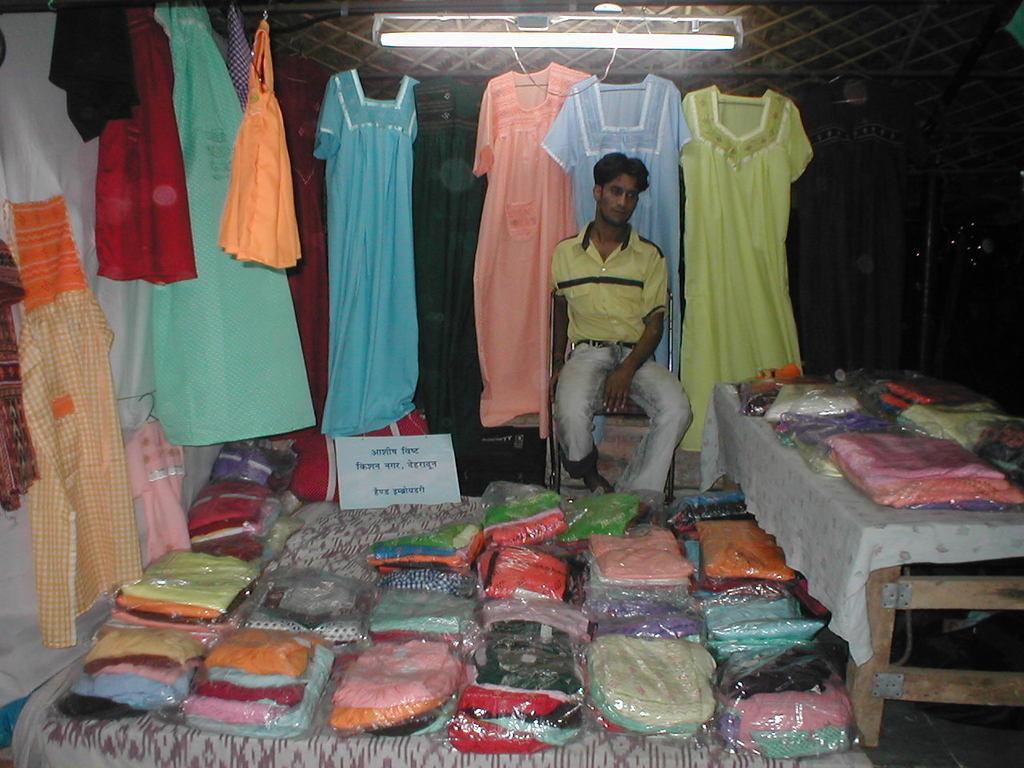How would you summarize this image in a sentence or two? In this picture we can see clothes packed in packets and there are tables. In the middle of the picture there are dresses and a person sitting in chair. At the top we can see light. In the center there is a name board. 